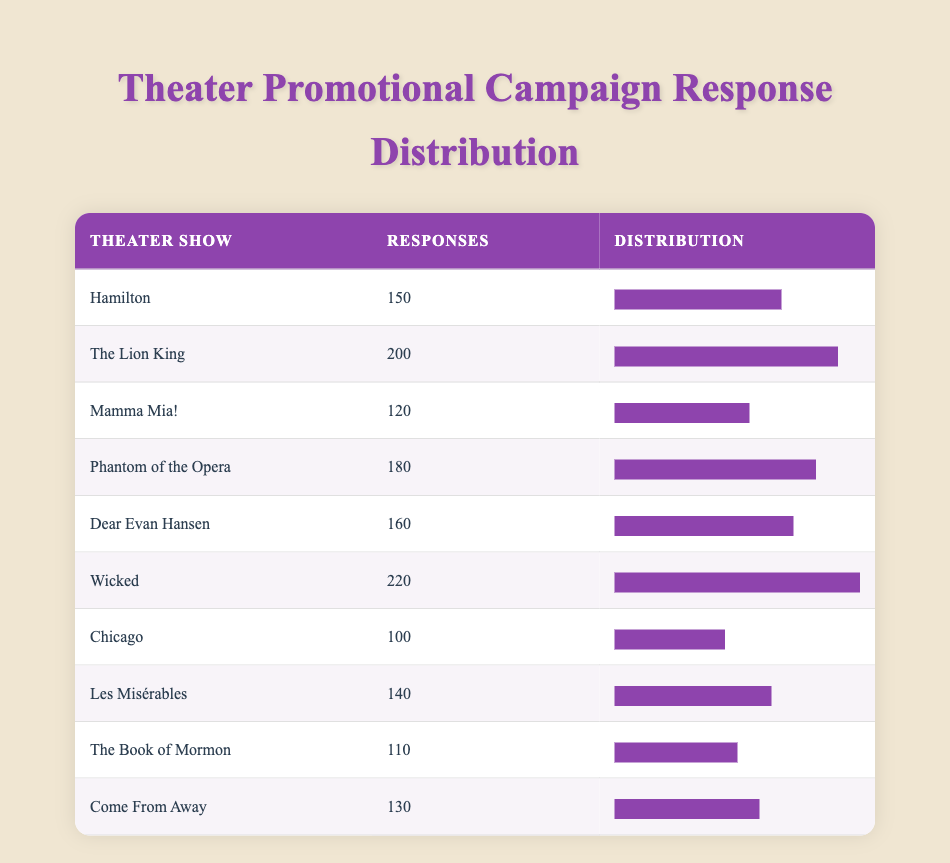What is the highest number of responses for a theater show? The table lists various theater shows along with their respective responses. By scanning through the "Responses" column, "Wicked" has the highest count with 220 responses.
Answer: 220 Which theater show received fewer responses: "Chicago" or "Mamma Mia!"? The table shows "Chicago" with 100 responses and "Mamma Mia!" with 120 responses. Since 100 is less than 120, "Chicago" received fewer responses.
Answer: Chicago What is the average number of responses across all theater shows? To calculate the average, add all responses: 150 + 200 + 120 + 180 + 160 + 220 + 100 + 140 + 110 + 130 = 1,610. With 10 shows in total, the average is 1,610 / 10 = 161.
Answer: 161 Is "Dear Evan Hansen" among the top three theater shows with the most responses? Listing the responses: "Wicked" (220), "The Lion King" (200), and "Phantom of the Opera" (180) are the top three. "Dear Evan Hansen," with 160 responses, is not within the top three.
Answer: No How many more responses did "Wicked" receive compared to "The Book of Mormon"? "Wicked" has 220 responses, while "The Book of Mormon" has 110. Subtracting gives: 220 - 110 = 110. Therefore, "Wicked" received 110 more responses.
Answer: 110 